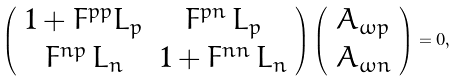Convert formula to latex. <formula><loc_0><loc_0><loc_500><loc_500>\left ( \begin{array} { c c } 1 + F ^ { p p } L _ { p } & F ^ { p n } \, L _ { p } \\ F ^ { n p } \, L _ { n } & 1 + F ^ { n n } \, L _ { n } \\ \end{array} \right ) \left ( \begin{array} { c } A _ { \omega p } \\ A _ { \omega n } \\ \end{array} \right ) = 0 ,</formula> 